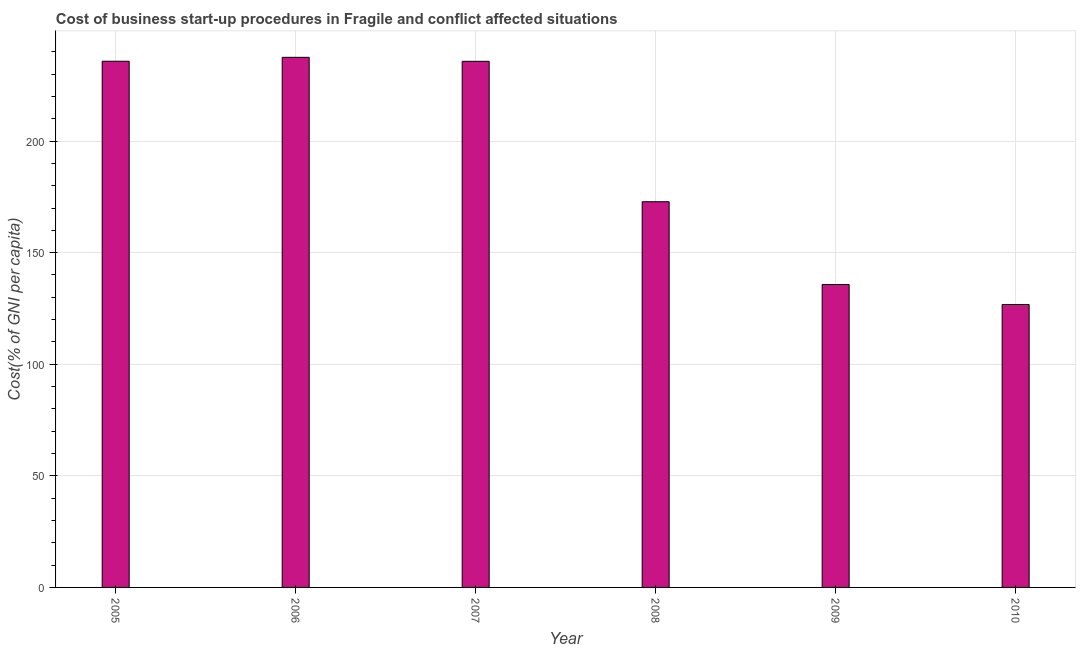Does the graph contain any zero values?
Give a very brief answer. No. Does the graph contain grids?
Make the answer very short. Yes. What is the title of the graph?
Provide a succinct answer. Cost of business start-up procedures in Fragile and conflict affected situations. What is the label or title of the Y-axis?
Offer a terse response. Cost(% of GNI per capita). What is the cost of business startup procedures in 2007?
Offer a terse response. 235.75. Across all years, what is the maximum cost of business startup procedures?
Offer a terse response. 237.54. Across all years, what is the minimum cost of business startup procedures?
Keep it short and to the point. 126.78. What is the sum of the cost of business startup procedures?
Keep it short and to the point. 1144.42. What is the difference between the cost of business startup procedures in 2008 and 2009?
Provide a succinct answer. 37.09. What is the average cost of business startup procedures per year?
Offer a very short reply. 190.74. What is the median cost of business startup procedures?
Provide a short and direct response. 204.29. Do a majority of the years between 2006 and 2007 (inclusive) have cost of business startup procedures greater than 140 %?
Provide a short and direct response. Yes. What is the ratio of the cost of business startup procedures in 2009 to that in 2010?
Your answer should be very brief. 1.07. What is the difference between the highest and the second highest cost of business startup procedures?
Provide a succinct answer. 1.76. Is the sum of the cost of business startup procedures in 2009 and 2010 greater than the maximum cost of business startup procedures across all years?
Make the answer very short. Yes. What is the difference between the highest and the lowest cost of business startup procedures?
Offer a terse response. 110.76. In how many years, is the cost of business startup procedures greater than the average cost of business startup procedures taken over all years?
Your answer should be very brief. 3. What is the Cost(% of GNI per capita) in 2005?
Ensure brevity in your answer.  235.78. What is the Cost(% of GNI per capita) in 2006?
Give a very brief answer. 237.54. What is the Cost(% of GNI per capita) in 2007?
Offer a very short reply. 235.75. What is the Cost(% of GNI per capita) in 2008?
Give a very brief answer. 172.83. What is the Cost(% of GNI per capita) in 2009?
Keep it short and to the point. 135.74. What is the Cost(% of GNI per capita) of 2010?
Give a very brief answer. 126.78. What is the difference between the Cost(% of GNI per capita) in 2005 and 2006?
Offer a terse response. -1.76. What is the difference between the Cost(% of GNI per capita) in 2005 and 2007?
Make the answer very short. 0.03. What is the difference between the Cost(% of GNI per capita) in 2005 and 2008?
Your response must be concise. 62.95. What is the difference between the Cost(% of GNI per capita) in 2005 and 2009?
Offer a very short reply. 100.05. What is the difference between the Cost(% of GNI per capita) in 2005 and 2010?
Make the answer very short. 109.01. What is the difference between the Cost(% of GNI per capita) in 2006 and 2007?
Keep it short and to the point. 1.79. What is the difference between the Cost(% of GNI per capita) in 2006 and 2008?
Offer a very short reply. 64.71. What is the difference between the Cost(% of GNI per capita) in 2006 and 2009?
Offer a very short reply. 101.8. What is the difference between the Cost(% of GNI per capita) in 2006 and 2010?
Offer a terse response. 110.76. What is the difference between the Cost(% of GNI per capita) in 2007 and 2008?
Provide a succinct answer. 62.92. What is the difference between the Cost(% of GNI per capita) in 2007 and 2009?
Offer a terse response. 100.02. What is the difference between the Cost(% of GNI per capita) in 2007 and 2010?
Make the answer very short. 108.98. What is the difference between the Cost(% of GNI per capita) in 2008 and 2009?
Provide a short and direct response. 37.09. What is the difference between the Cost(% of GNI per capita) in 2008 and 2010?
Offer a very short reply. 46.05. What is the difference between the Cost(% of GNI per capita) in 2009 and 2010?
Your answer should be compact. 8.96. What is the ratio of the Cost(% of GNI per capita) in 2005 to that in 2006?
Your response must be concise. 0.99. What is the ratio of the Cost(% of GNI per capita) in 2005 to that in 2007?
Offer a very short reply. 1. What is the ratio of the Cost(% of GNI per capita) in 2005 to that in 2008?
Provide a short and direct response. 1.36. What is the ratio of the Cost(% of GNI per capita) in 2005 to that in 2009?
Your answer should be very brief. 1.74. What is the ratio of the Cost(% of GNI per capita) in 2005 to that in 2010?
Offer a terse response. 1.86. What is the ratio of the Cost(% of GNI per capita) in 2006 to that in 2008?
Offer a terse response. 1.37. What is the ratio of the Cost(% of GNI per capita) in 2006 to that in 2010?
Your answer should be very brief. 1.87. What is the ratio of the Cost(% of GNI per capita) in 2007 to that in 2008?
Offer a terse response. 1.36. What is the ratio of the Cost(% of GNI per capita) in 2007 to that in 2009?
Offer a terse response. 1.74. What is the ratio of the Cost(% of GNI per capita) in 2007 to that in 2010?
Keep it short and to the point. 1.86. What is the ratio of the Cost(% of GNI per capita) in 2008 to that in 2009?
Offer a terse response. 1.27. What is the ratio of the Cost(% of GNI per capita) in 2008 to that in 2010?
Offer a terse response. 1.36. What is the ratio of the Cost(% of GNI per capita) in 2009 to that in 2010?
Ensure brevity in your answer.  1.07. 